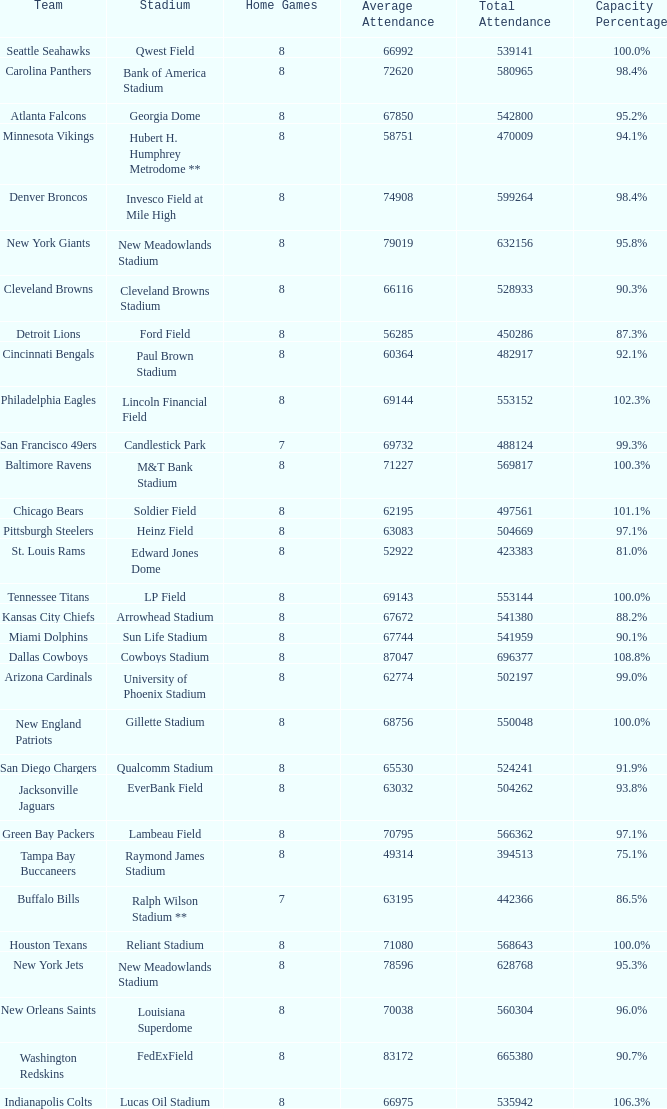What was average attendance when total attendance was 541380? 67672.0. 